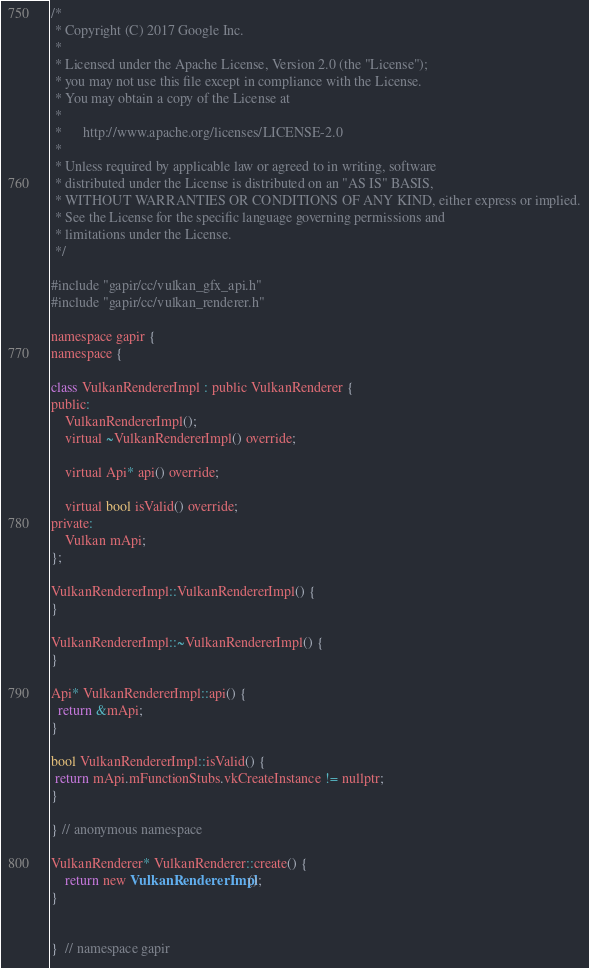Convert code to text. <code><loc_0><loc_0><loc_500><loc_500><_ObjectiveC_>/*
 * Copyright (C) 2017 Google Inc.
 *
 * Licensed under the Apache License, Version 2.0 (the "License");
 * you may not use this file except in compliance with the License.
 * You may obtain a copy of the License at
 *
 *      http://www.apache.org/licenses/LICENSE-2.0
 *
 * Unless required by applicable law or agreed to in writing, software
 * distributed under the License is distributed on an "AS IS" BASIS,
 * WITHOUT WARRANTIES OR CONDITIONS OF ANY KIND, either express or implied.
 * See the License for the specific language governing permissions and
 * limitations under the License.
 */

#include "gapir/cc/vulkan_gfx_api.h"
#include "gapir/cc/vulkan_renderer.h"

namespace gapir {
namespace {

class VulkanRendererImpl : public VulkanRenderer {
public:
    VulkanRendererImpl();
    virtual ~VulkanRendererImpl() override;

    virtual Api* api() override;

    virtual bool isValid() override;
private:
    Vulkan mApi;
};

VulkanRendererImpl::VulkanRendererImpl() {
}

VulkanRendererImpl::~VulkanRendererImpl() {
}

Api* VulkanRendererImpl::api() {
  return &mApi;
}

bool VulkanRendererImpl::isValid() {
 return mApi.mFunctionStubs.vkCreateInstance != nullptr;
}

} // anonymous namespace

VulkanRenderer* VulkanRenderer::create() {
    return new VulkanRendererImpl();
}


}  // namespace gapir
</code> 